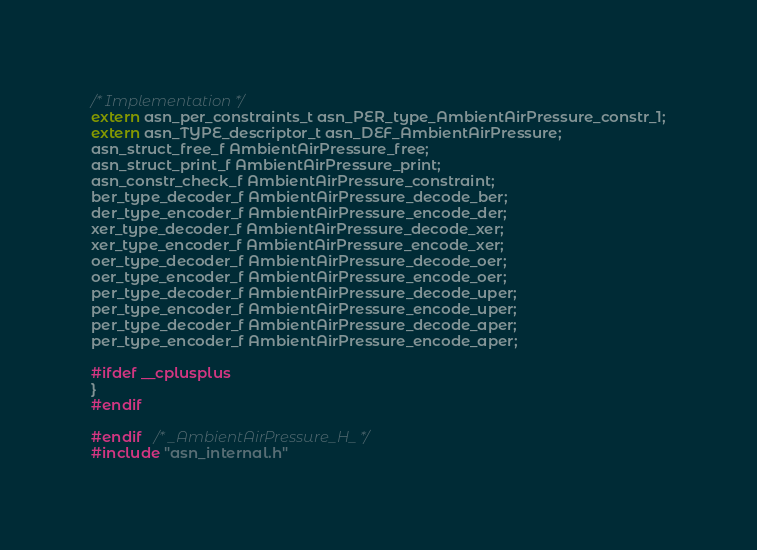<code> <loc_0><loc_0><loc_500><loc_500><_C_>
/* Implementation */
extern asn_per_constraints_t asn_PER_type_AmbientAirPressure_constr_1;
extern asn_TYPE_descriptor_t asn_DEF_AmbientAirPressure;
asn_struct_free_f AmbientAirPressure_free;
asn_struct_print_f AmbientAirPressure_print;
asn_constr_check_f AmbientAirPressure_constraint;
ber_type_decoder_f AmbientAirPressure_decode_ber;
der_type_encoder_f AmbientAirPressure_encode_der;
xer_type_decoder_f AmbientAirPressure_decode_xer;
xer_type_encoder_f AmbientAirPressure_encode_xer;
oer_type_decoder_f AmbientAirPressure_decode_oer;
oer_type_encoder_f AmbientAirPressure_encode_oer;
per_type_decoder_f AmbientAirPressure_decode_uper;
per_type_encoder_f AmbientAirPressure_encode_uper;
per_type_decoder_f AmbientAirPressure_decode_aper;
per_type_encoder_f AmbientAirPressure_encode_aper;

#ifdef __cplusplus
}
#endif

#endif	/* _AmbientAirPressure_H_ */
#include "asn_internal.h"
</code> 